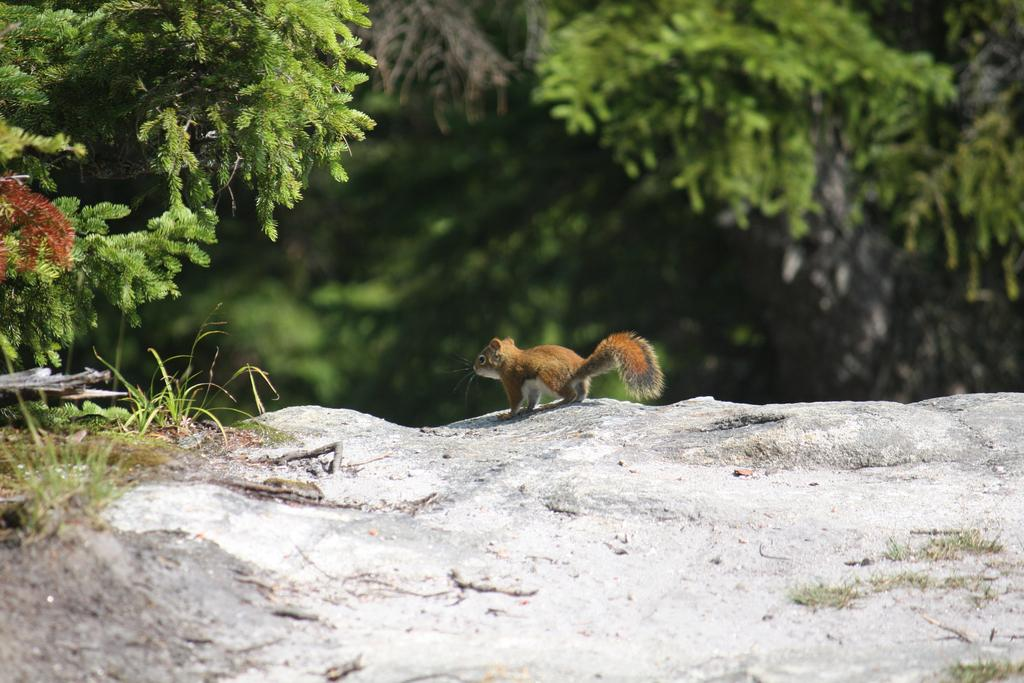What animal can be seen in the image? There is a squirrel on a rock in the image. What type of vegetation is visible in the image? There is grass visible in the image. What other natural elements can be seen in the image? There are trees in the image. What type of cup is being used by the squirrel in the image? There is no cup present in the image; the squirrel is on a rock. 